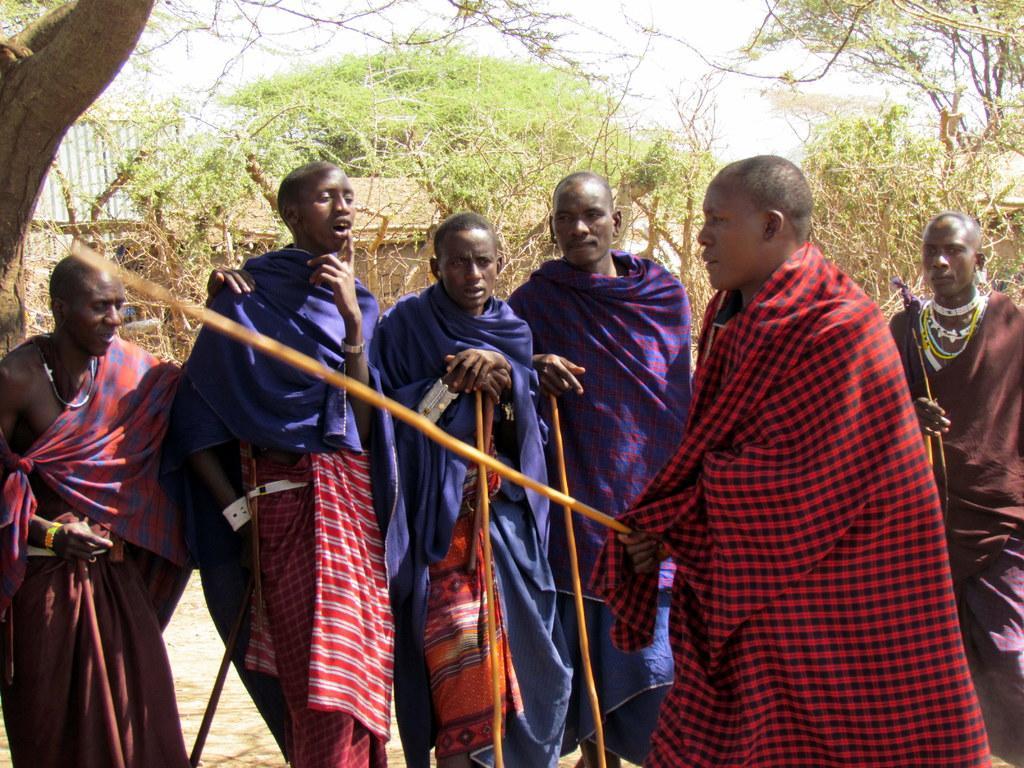Describe this image in one or two sentences. In this image we can see some people standing on the ground and holding some objects. There are some houses, some trees, some plants on the ground and at the top there is the sky. 